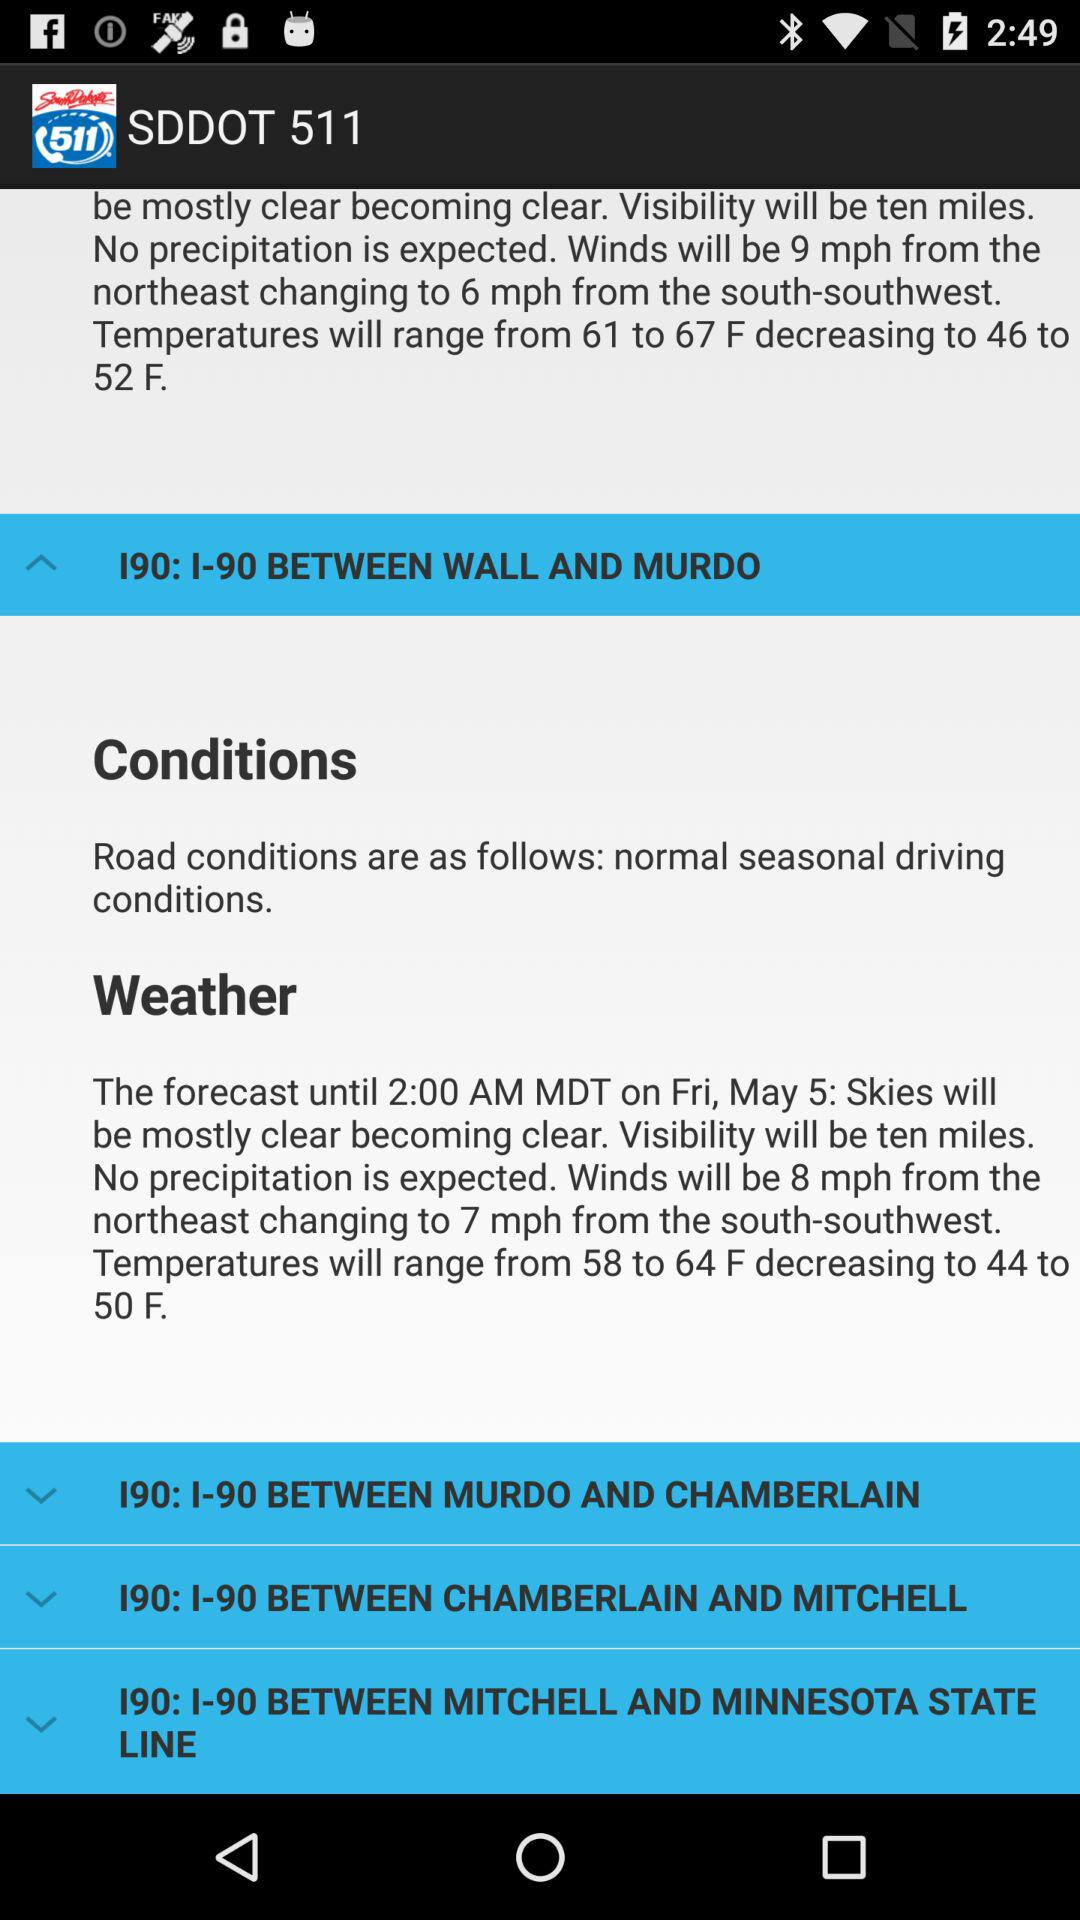What will be the Winds speed?
When the provided information is insufficient, respond with <no answer>. <no answer> 